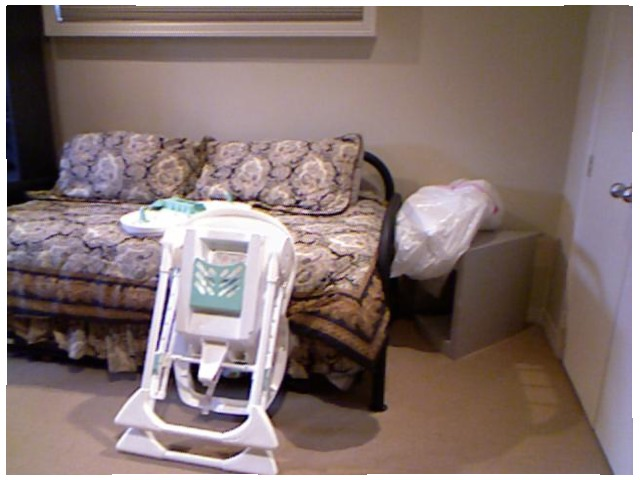<image>
Can you confirm if the door is behind the table? No. The door is not behind the table. From this viewpoint, the door appears to be positioned elsewhere in the scene. Is the garbage bag to the left of the door? Yes. From this viewpoint, the garbage bag is positioned to the left side relative to the door. 